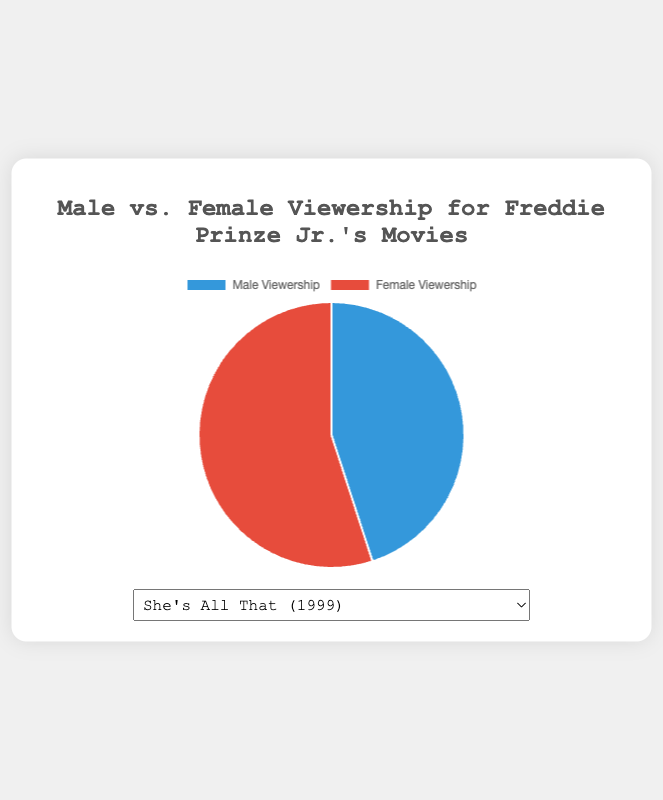What's the male-to-female viewership ratio for "She's All That"? The male viewership for "She's All That" is 45%, and the female viewership is 55%. To find the ratio, divide the male viewership percentage by the female viewership percentage: 45 / 55 = 0.8181, which simplifies to approximately 0.82.
Answer: 0.82 Which movie has the highest female viewership percentage? By comparing all the movies, "Summer Catch" has the highest female viewership percentage at 60%.
Answer: Summer Catch Is the male viewership for "Wing Commander" higher or lower than that of "Scooby-Doo"? The male viewership for "Wing Commander" is 53%, while for "Scooby-Doo" it is 48%. Since 53% is greater than 48%, "Wing Commander" has higher male viewership.
Answer: Higher How much more is the female viewership in "Down to You" compared to the male viewership in "She's All That"? The female viewership in "Down to You" is 56%, and the male viewership in "She's All That" is 45%. Subtract the latter from the former: 56 - 45 = 11.
Answer: 11 In "I Know What You Did Last Summer," how does the male viewership compare to the female viewership? Both the male and female viewership percentages for "I Know What You Did Last Summer" are 50%. Therefore, they are equal.
Answer: Equal What is the average female viewership percentage across all movies? The female viewership percentages across all movies are 55%, 50%, 52%, 60%, 47%, and 56%. Sum these values: 55 + 50 + 52 + 60 + 47 + 56 = 320. Divide by the number of movies, which is 6: 320 / 6 = 53.33.
Answer: 53.33 Which movie has the closest male and female viewership percentages? By comparing the differences between male and female percentages, "I Know What You Did Last Summer" has the closest, both being exactly 50%.
Answer: I Know What You Did Last Summer 